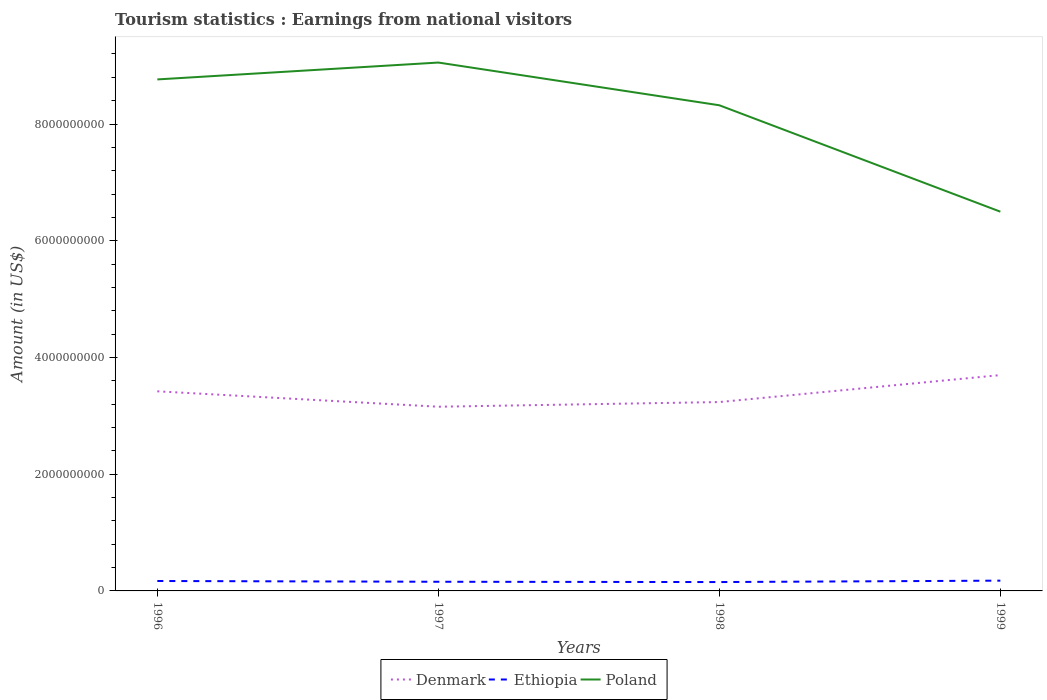How many different coloured lines are there?
Provide a succinct answer. 3. Across all years, what is the maximum earnings from national visitors in Poland?
Give a very brief answer. 6.50e+09. In which year was the earnings from national visitors in Poland maximum?
Your answer should be compact. 1999. What is the total earnings from national visitors in Denmark in the graph?
Give a very brief answer. 1.84e+08. What is the difference between the highest and the second highest earnings from national visitors in Denmark?
Your answer should be compact. 5.42e+08. Is the earnings from national visitors in Poland strictly greater than the earnings from national visitors in Denmark over the years?
Your answer should be very brief. No. How many lines are there?
Give a very brief answer. 3. How many years are there in the graph?
Offer a very short reply. 4. Are the values on the major ticks of Y-axis written in scientific E-notation?
Your response must be concise. No. Where does the legend appear in the graph?
Your answer should be very brief. Bottom center. How many legend labels are there?
Offer a very short reply. 3. How are the legend labels stacked?
Provide a succinct answer. Horizontal. What is the title of the graph?
Keep it short and to the point. Tourism statistics : Earnings from national visitors. Does "Ukraine" appear as one of the legend labels in the graph?
Your response must be concise. No. What is the label or title of the X-axis?
Offer a terse response. Years. What is the Amount (in US$) in Denmark in 1996?
Your response must be concise. 3.42e+09. What is the Amount (in US$) of Ethiopia in 1996?
Provide a short and direct response. 1.70e+08. What is the Amount (in US$) in Poland in 1996?
Provide a short and direct response. 8.76e+09. What is the Amount (in US$) in Denmark in 1997?
Your response must be concise. 3.16e+09. What is the Amount (in US$) in Ethiopia in 1997?
Give a very brief answer. 1.57e+08. What is the Amount (in US$) in Poland in 1997?
Your answer should be compact. 9.05e+09. What is the Amount (in US$) of Denmark in 1998?
Ensure brevity in your answer.  3.24e+09. What is the Amount (in US$) in Ethiopia in 1998?
Offer a terse response. 1.52e+08. What is the Amount (in US$) in Poland in 1998?
Offer a terse response. 8.32e+09. What is the Amount (in US$) in Denmark in 1999?
Make the answer very short. 3.70e+09. What is the Amount (in US$) in Ethiopia in 1999?
Ensure brevity in your answer.  1.76e+08. What is the Amount (in US$) in Poland in 1999?
Ensure brevity in your answer.  6.50e+09. Across all years, what is the maximum Amount (in US$) of Denmark?
Offer a terse response. 3.70e+09. Across all years, what is the maximum Amount (in US$) of Ethiopia?
Your response must be concise. 1.76e+08. Across all years, what is the maximum Amount (in US$) of Poland?
Your response must be concise. 9.05e+09. Across all years, what is the minimum Amount (in US$) in Denmark?
Offer a very short reply. 3.16e+09. Across all years, what is the minimum Amount (in US$) in Ethiopia?
Offer a very short reply. 1.52e+08. Across all years, what is the minimum Amount (in US$) in Poland?
Ensure brevity in your answer.  6.50e+09. What is the total Amount (in US$) of Denmark in the graph?
Your answer should be very brief. 1.35e+1. What is the total Amount (in US$) of Ethiopia in the graph?
Provide a short and direct response. 6.55e+08. What is the total Amount (in US$) in Poland in the graph?
Ensure brevity in your answer.  3.26e+1. What is the difference between the Amount (in US$) of Denmark in 1996 and that in 1997?
Provide a succinct answer. 2.64e+08. What is the difference between the Amount (in US$) in Ethiopia in 1996 and that in 1997?
Offer a very short reply. 1.30e+07. What is the difference between the Amount (in US$) of Poland in 1996 and that in 1997?
Your answer should be very brief. -2.89e+08. What is the difference between the Amount (in US$) of Denmark in 1996 and that in 1998?
Your answer should be compact. 1.84e+08. What is the difference between the Amount (in US$) of Ethiopia in 1996 and that in 1998?
Your answer should be very brief. 1.80e+07. What is the difference between the Amount (in US$) in Poland in 1996 and that in 1998?
Provide a short and direct response. 4.43e+08. What is the difference between the Amount (in US$) in Denmark in 1996 and that in 1999?
Make the answer very short. -2.78e+08. What is the difference between the Amount (in US$) of Ethiopia in 1996 and that in 1999?
Your answer should be very brief. -6.00e+06. What is the difference between the Amount (in US$) of Poland in 1996 and that in 1999?
Offer a very short reply. 2.27e+09. What is the difference between the Amount (in US$) of Denmark in 1997 and that in 1998?
Offer a terse response. -8.00e+07. What is the difference between the Amount (in US$) of Ethiopia in 1997 and that in 1998?
Provide a short and direct response. 5.00e+06. What is the difference between the Amount (in US$) in Poland in 1997 and that in 1998?
Keep it short and to the point. 7.32e+08. What is the difference between the Amount (in US$) of Denmark in 1997 and that in 1999?
Make the answer very short. -5.42e+08. What is the difference between the Amount (in US$) of Ethiopia in 1997 and that in 1999?
Make the answer very short. -1.90e+07. What is the difference between the Amount (in US$) in Poland in 1997 and that in 1999?
Provide a short and direct response. 2.56e+09. What is the difference between the Amount (in US$) in Denmark in 1998 and that in 1999?
Ensure brevity in your answer.  -4.62e+08. What is the difference between the Amount (in US$) in Ethiopia in 1998 and that in 1999?
Provide a short and direct response. -2.40e+07. What is the difference between the Amount (in US$) of Poland in 1998 and that in 1999?
Ensure brevity in your answer.  1.82e+09. What is the difference between the Amount (in US$) in Denmark in 1996 and the Amount (in US$) in Ethiopia in 1997?
Your answer should be compact. 3.26e+09. What is the difference between the Amount (in US$) in Denmark in 1996 and the Amount (in US$) in Poland in 1997?
Make the answer very short. -5.63e+09. What is the difference between the Amount (in US$) in Ethiopia in 1996 and the Amount (in US$) in Poland in 1997?
Your answer should be compact. -8.88e+09. What is the difference between the Amount (in US$) in Denmark in 1996 and the Amount (in US$) in Ethiopia in 1998?
Provide a short and direct response. 3.27e+09. What is the difference between the Amount (in US$) in Denmark in 1996 and the Amount (in US$) in Poland in 1998?
Ensure brevity in your answer.  -4.90e+09. What is the difference between the Amount (in US$) of Ethiopia in 1996 and the Amount (in US$) of Poland in 1998?
Give a very brief answer. -8.15e+09. What is the difference between the Amount (in US$) in Denmark in 1996 and the Amount (in US$) in Ethiopia in 1999?
Ensure brevity in your answer.  3.24e+09. What is the difference between the Amount (in US$) in Denmark in 1996 and the Amount (in US$) in Poland in 1999?
Offer a very short reply. -3.08e+09. What is the difference between the Amount (in US$) in Ethiopia in 1996 and the Amount (in US$) in Poland in 1999?
Provide a succinct answer. -6.33e+09. What is the difference between the Amount (in US$) in Denmark in 1997 and the Amount (in US$) in Ethiopia in 1998?
Keep it short and to the point. 3.00e+09. What is the difference between the Amount (in US$) in Denmark in 1997 and the Amount (in US$) in Poland in 1998?
Offer a terse response. -5.16e+09. What is the difference between the Amount (in US$) in Ethiopia in 1997 and the Amount (in US$) in Poland in 1998?
Offer a very short reply. -8.16e+09. What is the difference between the Amount (in US$) of Denmark in 1997 and the Amount (in US$) of Ethiopia in 1999?
Provide a succinct answer. 2.98e+09. What is the difference between the Amount (in US$) in Denmark in 1997 and the Amount (in US$) in Poland in 1999?
Provide a short and direct response. -3.34e+09. What is the difference between the Amount (in US$) of Ethiopia in 1997 and the Amount (in US$) of Poland in 1999?
Your response must be concise. -6.34e+09. What is the difference between the Amount (in US$) in Denmark in 1998 and the Amount (in US$) in Ethiopia in 1999?
Make the answer very short. 3.06e+09. What is the difference between the Amount (in US$) in Denmark in 1998 and the Amount (in US$) in Poland in 1999?
Your answer should be very brief. -3.26e+09. What is the difference between the Amount (in US$) in Ethiopia in 1998 and the Amount (in US$) in Poland in 1999?
Offer a terse response. -6.35e+09. What is the average Amount (in US$) of Denmark per year?
Your answer should be very brief. 3.38e+09. What is the average Amount (in US$) of Ethiopia per year?
Offer a very short reply. 1.64e+08. What is the average Amount (in US$) of Poland per year?
Your response must be concise. 8.16e+09. In the year 1996, what is the difference between the Amount (in US$) in Denmark and Amount (in US$) in Ethiopia?
Make the answer very short. 3.25e+09. In the year 1996, what is the difference between the Amount (in US$) of Denmark and Amount (in US$) of Poland?
Provide a short and direct response. -5.34e+09. In the year 1996, what is the difference between the Amount (in US$) in Ethiopia and Amount (in US$) in Poland?
Provide a short and direct response. -8.59e+09. In the year 1997, what is the difference between the Amount (in US$) in Denmark and Amount (in US$) in Ethiopia?
Provide a succinct answer. 3.00e+09. In the year 1997, what is the difference between the Amount (in US$) of Denmark and Amount (in US$) of Poland?
Your answer should be very brief. -5.90e+09. In the year 1997, what is the difference between the Amount (in US$) of Ethiopia and Amount (in US$) of Poland?
Offer a very short reply. -8.90e+09. In the year 1998, what is the difference between the Amount (in US$) in Denmark and Amount (in US$) in Ethiopia?
Offer a very short reply. 3.08e+09. In the year 1998, what is the difference between the Amount (in US$) of Denmark and Amount (in US$) of Poland?
Offer a terse response. -5.08e+09. In the year 1998, what is the difference between the Amount (in US$) in Ethiopia and Amount (in US$) in Poland?
Your response must be concise. -8.17e+09. In the year 1999, what is the difference between the Amount (in US$) of Denmark and Amount (in US$) of Ethiopia?
Your answer should be very brief. 3.52e+09. In the year 1999, what is the difference between the Amount (in US$) of Denmark and Amount (in US$) of Poland?
Your answer should be compact. -2.80e+09. In the year 1999, what is the difference between the Amount (in US$) in Ethiopia and Amount (in US$) in Poland?
Your response must be concise. -6.32e+09. What is the ratio of the Amount (in US$) in Denmark in 1996 to that in 1997?
Ensure brevity in your answer.  1.08. What is the ratio of the Amount (in US$) in Ethiopia in 1996 to that in 1997?
Provide a succinct answer. 1.08. What is the ratio of the Amount (in US$) of Poland in 1996 to that in 1997?
Give a very brief answer. 0.97. What is the ratio of the Amount (in US$) of Denmark in 1996 to that in 1998?
Ensure brevity in your answer.  1.06. What is the ratio of the Amount (in US$) in Ethiopia in 1996 to that in 1998?
Offer a terse response. 1.12. What is the ratio of the Amount (in US$) of Poland in 1996 to that in 1998?
Keep it short and to the point. 1.05. What is the ratio of the Amount (in US$) of Denmark in 1996 to that in 1999?
Provide a succinct answer. 0.92. What is the ratio of the Amount (in US$) of Ethiopia in 1996 to that in 1999?
Your answer should be compact. 0.97. What is the ratio of the Amount (in US$) in Poland in 1996 to that in 1999?
Your response must be concise. 1.35. What is the ratio of the Amount (in US$) in Denmark in 1997 to that in 1998?
Offer a very short reply. 0.98. What is the ratio of the Amount (in US$) of Ethiopia in 1997 to that in 1998?
Provide a succinct answer. 1.03. What is the ratio of the Amount (in US$) in Poland in 1997 to that in 1998?
Offer a terse response. 1.09. What is the ratio of the Amount (in US$) in Denmark in 1997 to that in 1999?
Provide a succinct answer. 0.85. What is the ratio of the Amount (in US$) in Ethiopia in 1997 to that in 1999?
Offer a very short reply. 0.89. What is the ratio of the Amount (in US$) in Poland in 1997 to that in 1999?
Provide a succinct answer. 1.39. What is the ratio of the Amount (in US$) in Denmark in 1998 to that in 1999?
Provide a short and direct response. 0.88. What is the ratio of the Amount (in US$) in Ethiopia in 1998 to that in 1999?
Make the answer very short. 0.86. What is the ratio of the Amount (in US$) of Poland in 1998 to that in 1999?
Give a very brief answer. 1.28. What is the difference between the highest and the second highest Amount (in US$) of Denmark?
Give a very brief answer. 2.78e+08. What is the difference between the highest and the second highest Amount (in US$) in Ethiopia?
Offer a very short reply. 6.00e+06. What is the difference between the highest and the second highest Amount (in US$) of Poland?
Make the answer very short. 2.89e+08. What is the difference between the highest and the lowest Amount (in US$) in Denmark?
Provide a succinct answer. 5.42e+08. What is the difference between the highest and the lowest Amount (in US$) of Ethiopia?
Make the answer very short. 2.40e+07. What is the difference between the highest and the lowest Amount (in US$) in Poland?
Ensure brevity in your answer.  2.56e+09. 